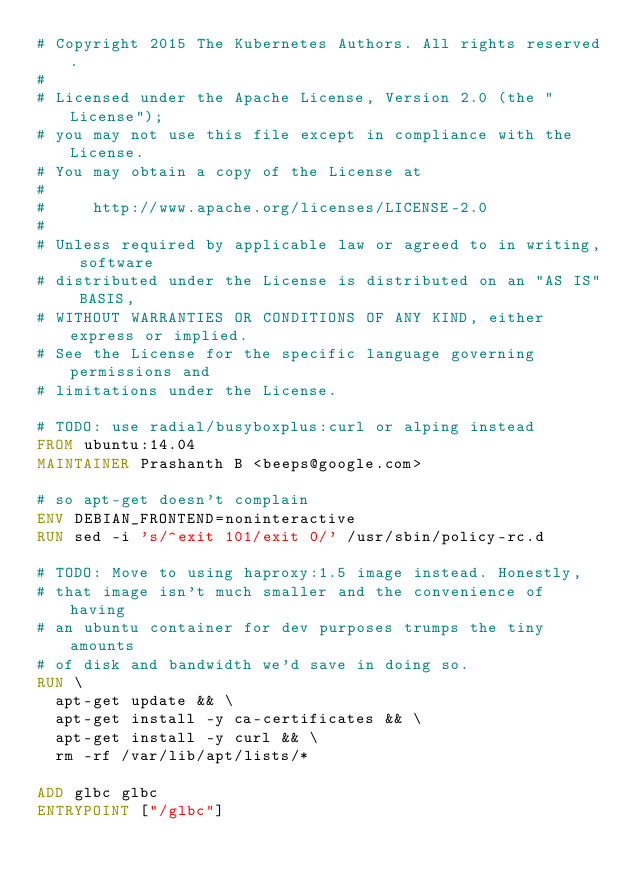Convert code to text. <code><loc_0><loc_0><loc_500><loc_500><_Dockerfile_># Copyright 2015 The Kubernetes Authors. All rights reserved.
#
# Licensed under the Apache License, Version 2.0 (the "License");
# you may not use this file except in compliance with the License.
# You may obtain a copy of the License at
#
#     http://www.apache.org/licenses/LICENSE-2.0
#
# Unless required by applicable law or agreed to in writing, software
# distributed under the License is distributed on an "AS IS" BASIS,
# WITHOUT WARRANTIES OR CONDITIONS OF ANY KIND, either express or implied.
# See the License for the specific language governing permissions and
# limitations under the License.

# TODO: use radial/busyboxplus:curl or alping instead
FROM ubuntu:14.04
MAINTAINER Prashanth B <beeps@google.com>

# so apt-get doesn't complain
ENV DEBIAN_FRONTEND=noninteractive
RUN sed -i 's/^exit 101/exit 0/' /usr/sbin/policy-rc.d

# TODO: Move to using haproxy:1.5 image instead. Honestly,
# that image isn't much smaller and the convenience of having
# an ubuntu container for dev purposes trumps the tiny amounts
# of disk and bandwidth we'd save in doing so.
RUN \
  apt-get update && \
  apt-get install -y ca-certificates && \
  apt-get install -y curl && \
  rm -rf /var/lib/apt/lists/*

ADD glbc glbc
ENTRYPOINT ["/glbc"]
</code> 